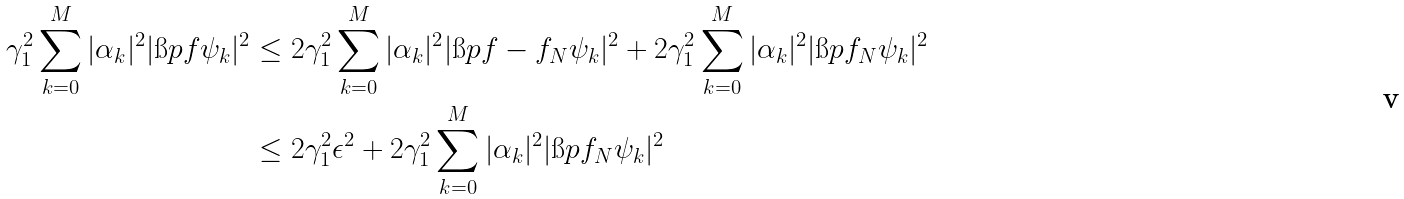Convert formula to latex. <formula><loc_0><loc_0><loc_500><loc_500>\gamma _ { 1 } ^ { 2 } \sum _ { k = 0 } ^ { M } | \alpha _ { k } | ^ { 2 } | \i p { f } { \psi _ { k } } | ^ { 2 } & \leq 2 \gamma _ { 1 } ^ { 2 } \sum _ { k = 0 } ^ { M } | \alpha _ { k } | ^ { 2 } | \i p { f - f _ { N } } { \psi _ { k } } | ^ { 2 } + 2 \gamma _ { 1 } ^ { 2 } \sum _ { k = 0 } ^ { M } | \alpha _ { k } | ^ { 2 } | \i p { f _ { N } } { \psi _ { k } } | ^ { 2 } \\ & \leq 2 \gamma _ { 1 } ^ { 2 } \epsilon ^ { 2 } + 2 \gamma _ { 1 } ^ { 2 } \sum _ { k = 0 } ^ { M } | \alpha _ { k } | ^ { 2 } | \i p { f _ { N } } { \psi _ { k } } | ^ { 2 }</formula> 